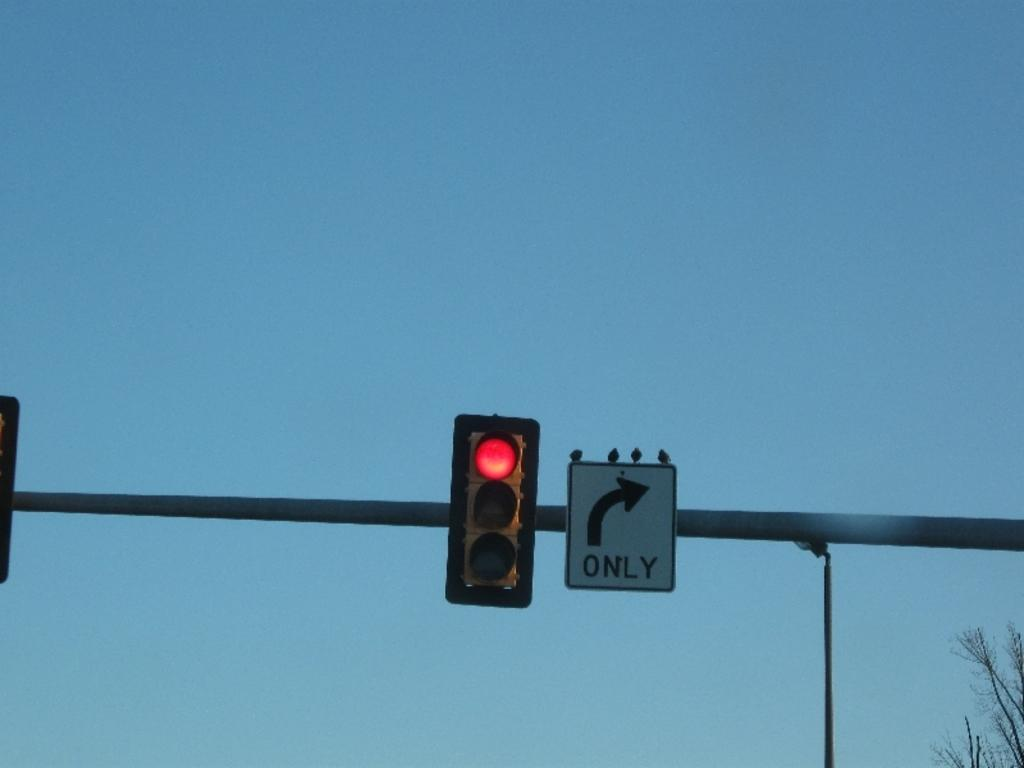<image>
Summarize the visual content of the image. A white sign with a black arrow turning to the right that dictates you turn right only. There is a red traffic light to the left of the sign.. 